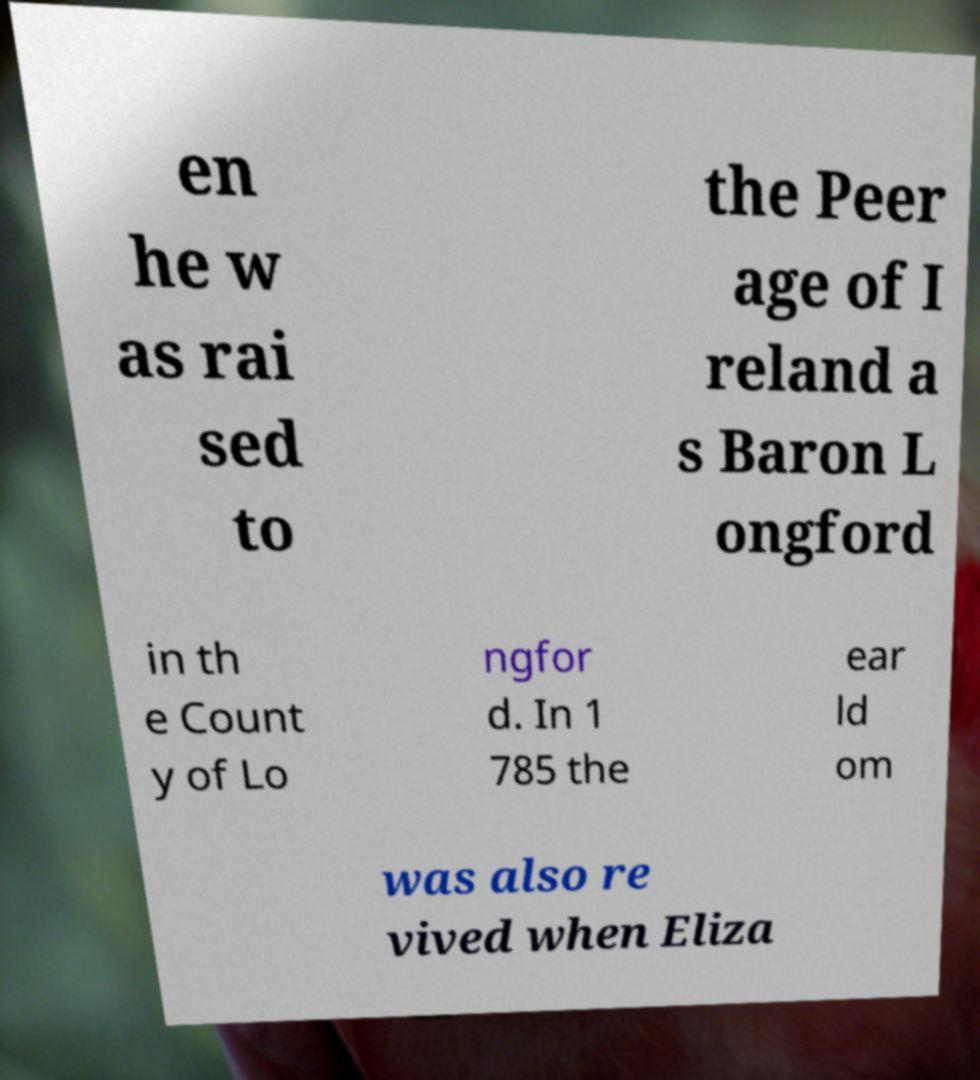There's text embedded in this image that I need extracted. Can you transcribe it verbatim? en he w as rai sed to the Peer age of I reland a s Baron L ongford in th e Count y of Lo ngfor d. In 1 785 the ear ld om was also re vived when Eliza 